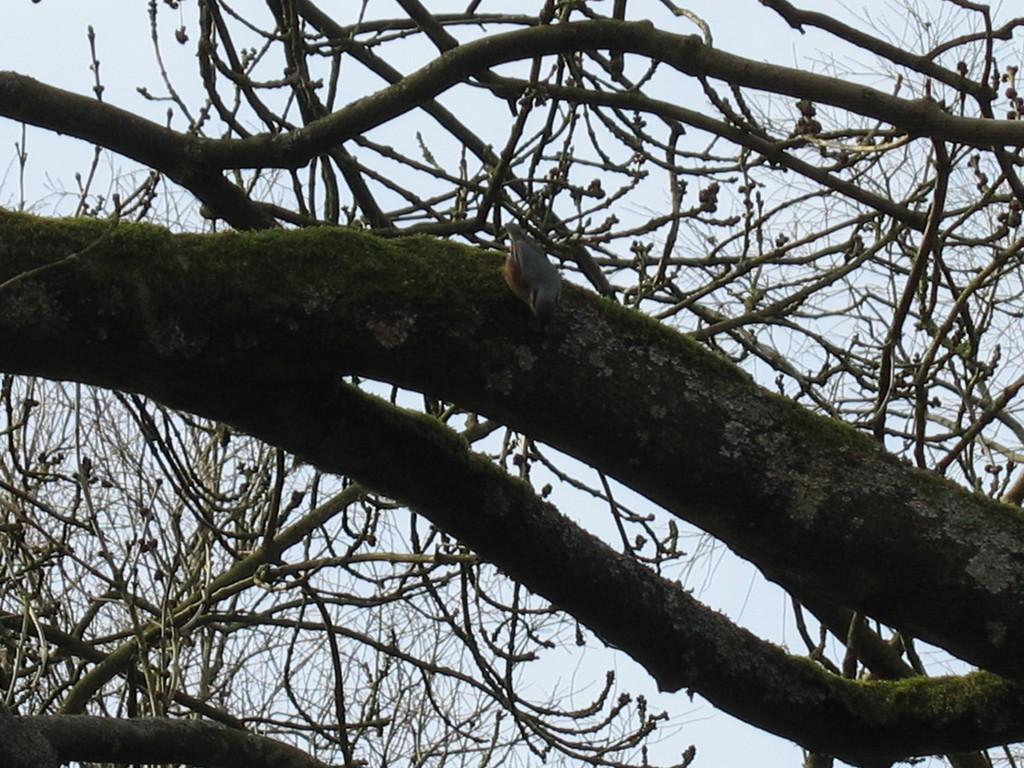How would you summarize this image in a sentence or two? There is a bird in the center of the image on a trunk and there are branches and sky in the background area. 